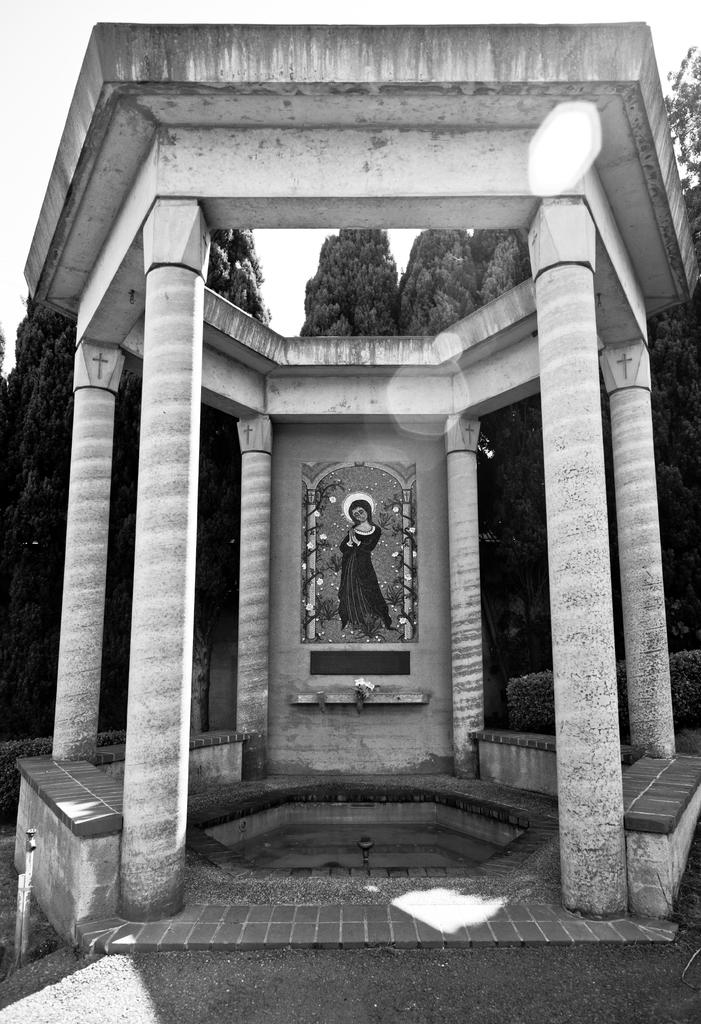What is the color scheme of the image? The image is black and white. What architectural features can be seen in the image? There are pillars in the image. What is hanging on the wall in the image? There is a frame on the wall in the image. What natural element is visible in the image? There is water visible in the image. What type of vegetation is present in the image? There are trees in the image. How many times does the person jump in the image? There is no person present in the image, and therefore no jumping can be observed. What type of calendar is hanging on the wall in the image? There is no calendar present in the image. 